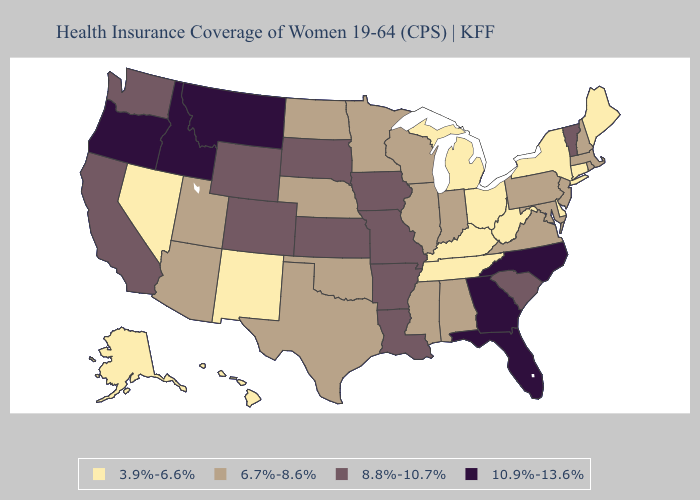Does Utah have a higher value than Nevada?
Keep it brief. Yes. Does Arkansas have the lowest value in the USA?
Give a very brief answer. No. What is the lowest value in the West?
Keep it brief. 3.9%-6.6%. Which states have the lowest value in the USA?
Quick response, please. Alaska, Connecticut, Delaware, Hawaii, Kentucky, Maine, Michigan, Nevada, New Mexico, New York, Ohio, Tennessee, West Virginia. Name the states that have a value in the range 6.7%-8.6%?
Keep it brief. Alabama, Arizona, Illinois, Indiana, Maryland, Massachusetts, Minnesota, Mississippi, Nebraska, New Hampshire, New Jersey, North Dakota, Oklahoma, Pennsylvania, Rhode Island, Texas, Utah, Virginia, Wisconsin. Among the states that border Maryland , which have the highest value?
Concise answer only. Pennsylvania, Virginia. What is the value of Ohio?
Be succinct. 3.9%-6.6%. Name the states that have a value in the range 6.7%-8.6%?
Be succinct. Alabama, Arizona, Illinois, Indiana, Maryland, Massachusetts, Minnesota, Mississippi, Nebraska, New Hampshire, New Jersey, North Dakota, Oklahoma, Pennsylvania, Rhode Island, Texas, Utah, Virginia, Wisconsin. Name the states that have a value in the range 10.9%-13.6%?
Answer briefly. Florida, Georgia, Idaho, Montana, North Carolina, Oregon. What is the lowest value in the USA?
Quick response, please. 3.9%-6.6%. What is the value of Pennsylvania?
Concise answer only. 6.7%-8.6%. Does the map have missing data?
Short answer required. No. What is the value of New Jersey?
Quick response, please. 6.7%-8.6%. What is the value of Montana?
Write a very short answer. 10.9%-13.6%. What is the value of Ohio?
Give a very brief answer. 3.9%-6.6%. 